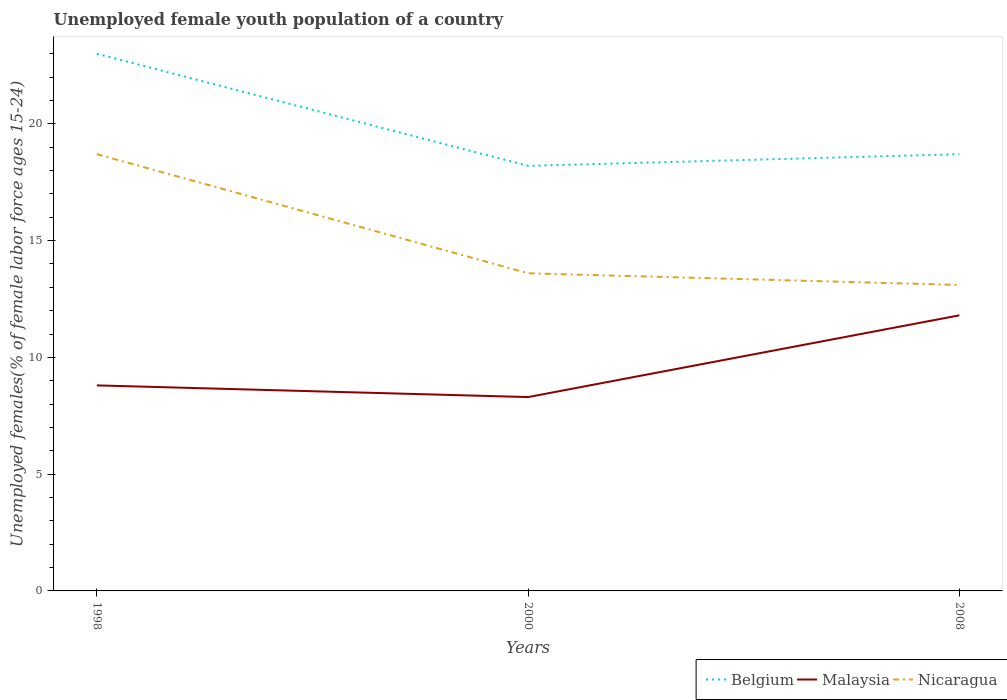How many different coloured lines are there?
Offer a very short reply. 3. Across all years, what is the maximum percentage of unemployed female youth population in Malaysia?
Offer a terse response. 8.3. In which year was the percentage of unemployed female youth population in Malaysia maximum?
Your answer should be very brief. 2000. What is the difference between the highest and the second highest percentage of unemployed female youth population in Malaysia?
Offer a terse response. 3.5. How many years are there in the graph?
Offer a terse response. 3. What is the difference between two consecutive major ticks on the Y-axis?
Provide a short and direct response. 5. Does the graph contain any zero values?
Make the answer very short. No. Does the graph contain grids?
Offer a terse response. No. How many legend labels are there?
Offer a terse response. 3. What is the title of the graph?
Make the answer very short. Unemployed female youth population of a country. Does "Togo" appear as one of the legend labels in the graph?
Provide a succinct answer. No. What is the label or title of the X-axis?
Offer a very short reply. Years. What is the label or title of the Y-axis?
Provide a succinct answer. Unemployed females(% of female labor force ages 15-24). What is the Unemployed females(% of female labor force ages 15-24) of Belgium in 1998?
Offer a very short reply. 23. What is the Unemployed females(% of female labor force ages 15-24) of Malaysia in 1998?
Your response must be concise. 8.8. What is the Unemployed females(% of female labor force ages 15-24) of Nicaragua in 1998?
Your answer should be very brief. 18.7. What is the Unemployed females(% of female labor force ages 15-24) in Belgium in 2000?
Offer a very short reply. 18.2. What is the Unemployed females(% of female labor force ages 15-24) of Malaysia in 2000?
Ensure brevity in your answer.  8.3. What is the Unemployed females(% of female labor force ages 15-24) of Nicaragua in 2000?
Your response must be concise. 13.6. What is the Unemployed females(% of female labor force ages 15-24) of Belgium in 2008?
Make the answer very short. 18.7. What is the Unemployed females(% of female labor force ages 15-24) of Malaysia in 2008?
Ensure brevity in your answer.  11.8. What is the Unemployed females(% of female labor force ages 15-24) in Nicaragua in 2008?
Ensure brevity in your answer.  13.1. Across all years, what is the maximum Unemployed females(% of female labor force ages 15-24) of Malaysia?
Provide a short and direct response. 11.8. Across all years, what is the maximum Unemployed females(% of female labor force ages 15-24) of Nicaragua?
Provide a short and direct response. 18.7. Across all years, what is the minimum Unemployed females(% of female labor force ages 15-24) of Belgium?
Your answer should be compact. 18.2. Across all years, what is the minimum Unemployed females(% of female labor force ages 15-24) in Malaysia?
Your answer should be compact. 8.3. Across all years, what is the minimum Unemployed females(% of female labor force ages 15-24) of Nicaragua?
Offer a terse response. 13.1. What is the total Unemployed females(% of female labor force ages 15-24) of Belgium in the graph?
Offer a terse response. 59.9. What is the total Unemployed females(% of female labor force ages 15-24) in Malaysia in the graph?
Your response must be concise. 28.9. What is the total Unemployed females(% of female labor force ages 15-24) in Nicaragua in the graph?
Give a very brief answer. 45.4. What is the difference between the Unemployed females(% of female labor force ages 15-24) of Belgium in 1998 and that in 2000?
Your answer should be very brief. 4.8. What is the difference between the Unemployed females(% of female labor force ages 15-24) of Belgium in 1998 and the Unemployed females(% of female labor force ages 15-24) of Nicaragua in 2000?
Provide a short and direct response. 9.4. What is the difference between the Unemployed females(% of female labor force ages 15-24) of Belgium in 1998 and the Unemployed females(% of female labor force ages 15-24) of Malaysia in 2008?
Your response must be concise. 11.2. What is the difference between the Unemployed females(% of female labor force ages 15-24) of Belgium in 2000 and the Unemployed females(% of female labor force ages 15-24) of Nicaragua in 2008?
Your answer should be compact. 5.1. What is the difference between the Unemployed females(% of female labor force ages 15-24) in Malaysia in 2000 and the Unemployed females(% of female labor force ages 15-24) in Nicaragua in 2008?
Make the answer very short. -4.8. What is the average Unemployed females(% of female labor force ages 15-24) of Belgium per year?
Offer a very short reply. 19.97. What is the average Unemployed females(% of female labor force ages 15-24) in Malaysia per year?
Make the answer very short. 9.63. What is the average Unemployed females(% of female labor force ages 15-24) of Nicaragua per year?
Provide a short and direct response. 15.13. In the year 1998, what is the difference between the Unemployed females(% of female labor force ages 15-24) of Belgium and Unemployed females(% of female labor force ages 15-24) of Nicaragua?
Provide a short and direct response. 4.3. In the year 1998, what is the difference between the Unemployed females(% of female labor force ages 15-24) of Malaysia and Unemployed females(% of female labor force ages 15-24) of Nicaragua?
Keep it short and to the point. -9.9. In the year 2000, what is the difference between the Unemployed females(% of female labor force ages 15-24) in Belgium and Unemployed females(% of female labor force ages 15-24) in Nicaragua?
Your answer should be compact. 4.6. In the year 2000, what is the difference between the Unemployed females(% of female labor force ages 15-24) in Malaysia and Unemployed females(% of female labor force ages 15-24) in Nicaragua?
Offer a very short reply. -5.3. In the year 2008, what is the difference between the Unemployed females(% of female labor force ages 15-24) in Belgium and Unemployed females(% of female labor force ages 15-24) in Nicaragua?
Provide a short and direct response. 5.6. In the year 2008, what is the difference between the Unemployed females(% of female labor force ages 15-24) in Malaysia and Unemployed females(% of female labor force ages 15-24) in Nicaragua?
Provide a succinct answer. -1.3. What is the ratio of the Unemployed females(% of female labor force ages 15-24) of Belgium in 1998 to that in 2000?
Your response must be concise. 1.26. What is the ratio of the Unemployed females(% of female labor force ages 15-24) of Malaysia in 1998 to that in 2000?
Ensure brevity in your answer.  1.06. What is the ratio of the Unemployed females(% of female labor force ages 15-24) of Nicaragua in 1998 to that in 2000?
Make the answer very short. 1.38. What is the ratio of the Unemployed females(% of female labor force ages 15-24) in Belgium in 1998 to that in 2008?
Ensure brevity in your answer.  1.23. What is the ratio of the Unemployed females(% of female labor force ages 15-24) of Malaysia in 1998 to that in 2008?
Offer a very short reply. 0.75. What is the ratio of the Unemployed females(% of female labor force ages 15-24) of Nicaragua in 1998 to that in 2008?
Make the answer very short. 1.43. What is the ratio of the Unemployed females(% of female labor force ages 15-24) of Belgium in 2000 to that in 2008?
Provide a short and direct response. 0.97. What is the ratio of the Unemployed females(% of female labor force ages 15-24) in Malaysia in 2000 to that in 2008?
Make the answer very short. 0.7. What is the ratio of the Unemployed females(% of female labor force ages 15-24) of Nicaragua in 2000 to that in 2008?
Provide a short and direct response. 1.04. What is the difference between the highest and the second highest Unemployed females(% of female labor force ages 15-24) in Belgium?
Your answer should be compact. 4.3. What is the difference between the highest and the second highest Unemployed females(% of female labor force ages 15-24) in Malaysia?
Offer a very short reply. 3. What is the difference between the highest and the lowest Unemployed females(% of female labor force ages 15-24) in Malaysia?
Provide a short and direct response. 3.5. 